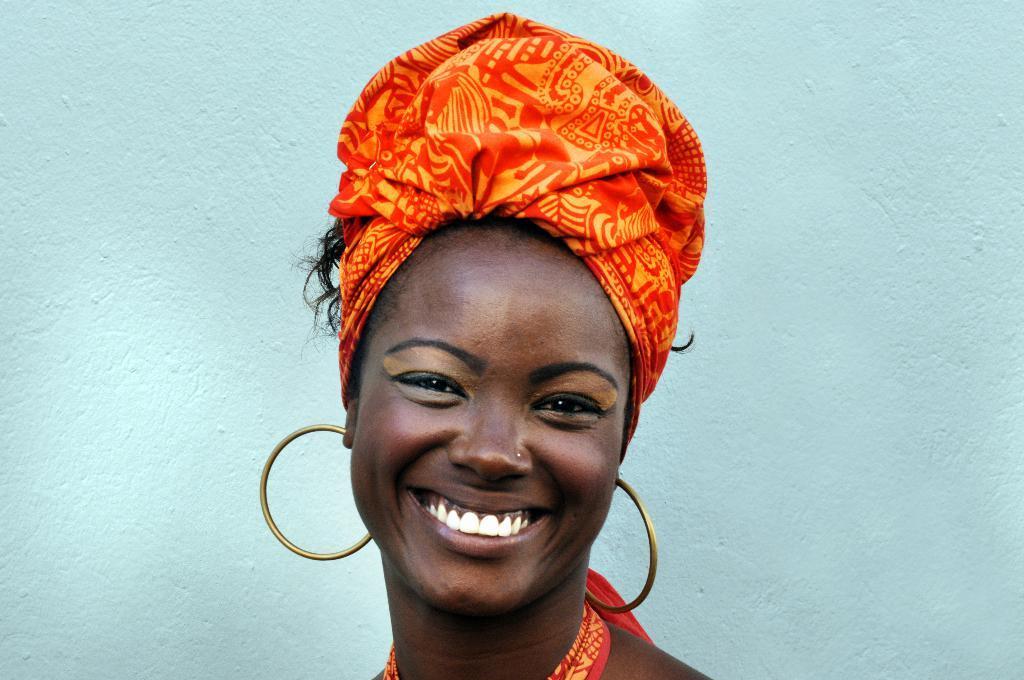Describe this image in one or two sentences. In this picture there is a woman smiling. At the back there is a wall. 